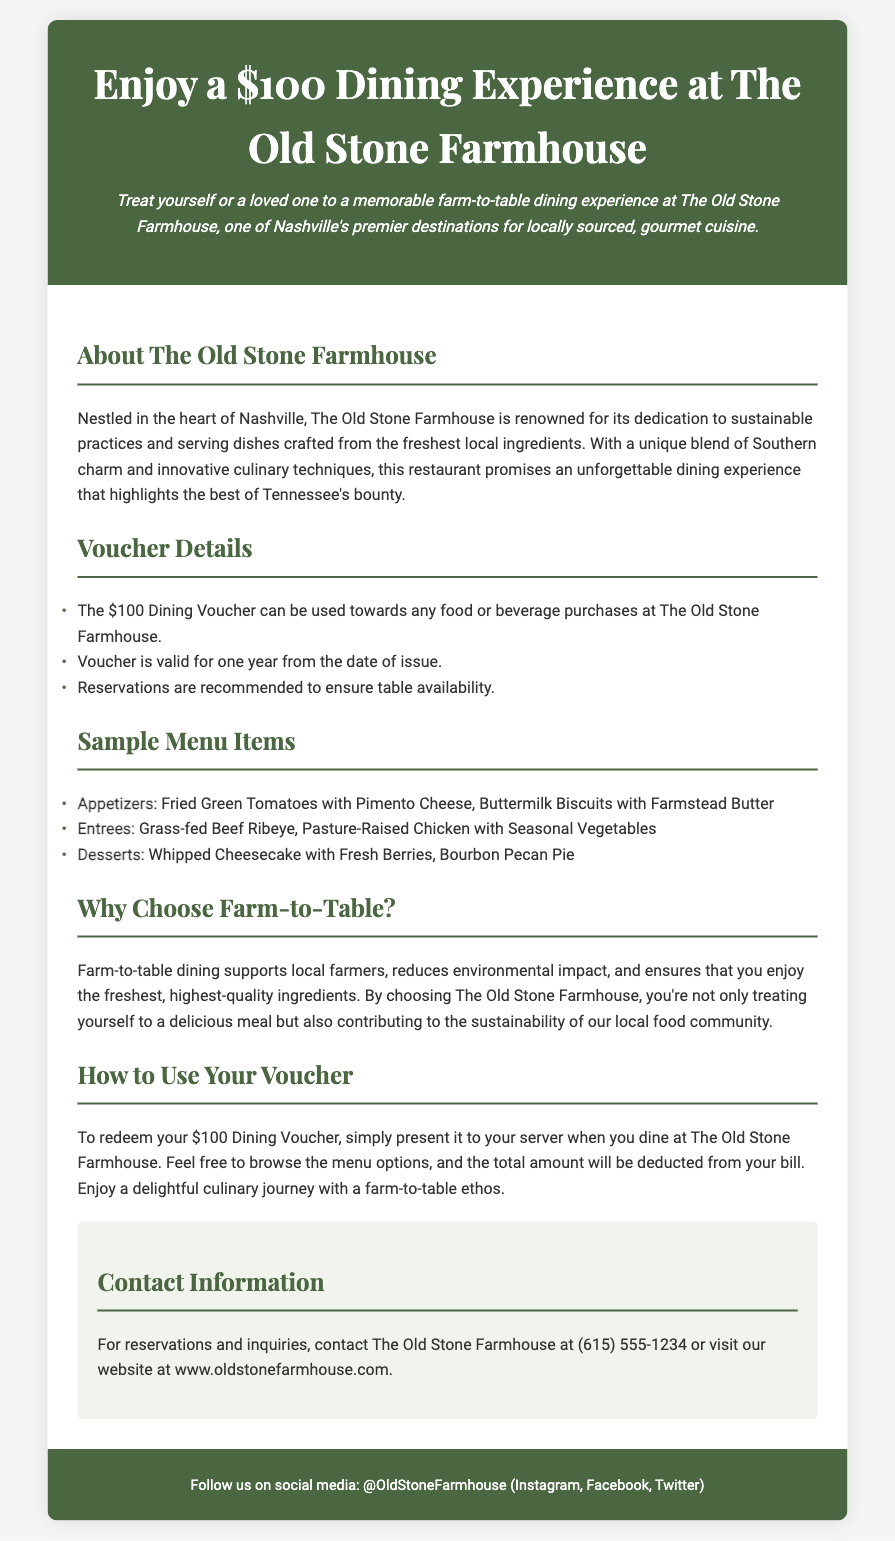What is the value of the dining voucher? The voucher is valued at $100 for dining at The Old Stone Farmhouse.
Answer: $100 How long is the voucher valid for? The document states that the voucher is valid for one year from the date of issue.
Answer: One year What type of cuisine does The Old Stone Farmhouse serve? The restaurant is known for farm-to-table dining, highlighting locally sourced ingredients.
Answer: Farm-to-table What are two sample appetizer items listed? The document lists Fried Green Tomatoes with Pimento Cheese and Buttermilk Biscuits with Farmstead Butter as appetizers.
Answer: Fried Green Tomatoes with Pimento Cheese, Buttermilk Biscuits with Farmstead Butter What is the contact number for reservations? The document provides a contact number for the restaurant which is (615) 555-1234.
Answer: (615) 555-1234 Why should customers choose farm-to-table dining? Farm-to-table dining supports local farmers, reduces environmental impact, and ensures fresh, high-quality ingredients.
Answer: Support local farmers, reduce environmental impact, fresh ingredients How should the voucher be redeemed? The voucher should be presented to the server when dining at The Old Stone Farmhouse.
Answer: Present to the server What is a suggested dessert option from the sample menu? The document mentions Whipped Cheesecake with Fresh Berries and Bourbon Pecan Pie as dessert options.
Answer: Whipped Cheesecake with Fresh Berries, Bourbon Pecan Pie What is the recommended action to ensure table availability? Reservations are recommended to ensure table availability according to the voucher details.
Answer: Reservations are recommended 